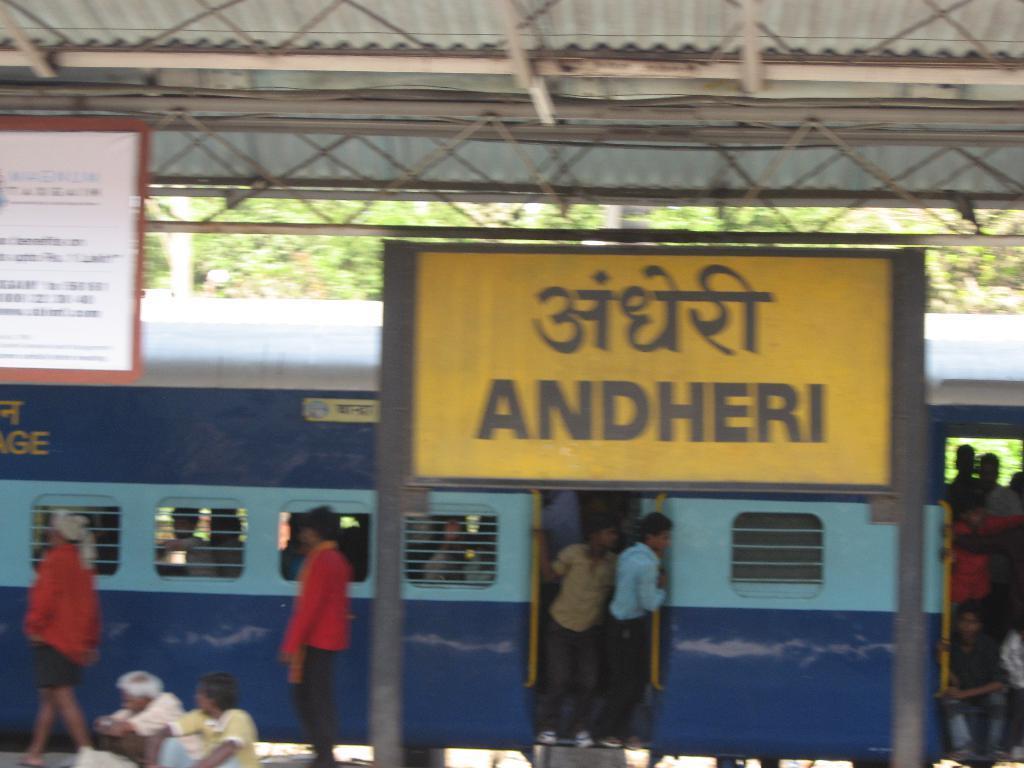In one or two sentences, can you explain what this image depicts? In this image, this looks like a name board, which is attached to the poles. This is the train. I can see the passengers standing and sitting in the train. There are two people walking. On the right side of the image, that looks like a board. I think this picture was taken in the railway station. In the background, these look like the trees. At the bottom of the image, there are two people sitting. 